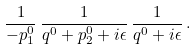<formula> <loc_0><loc_0><loc_500><loc_500>\frac { 1 } { - p _ { 1 } ^ { 0 } } \, \frac { 1 } { q ^ { 0 } + p _ { 2 } ^ { 0 } + i \epsilon } \, \frac { 1 } { q ^ { 0 } + i \epsilon } \, .</formula> 